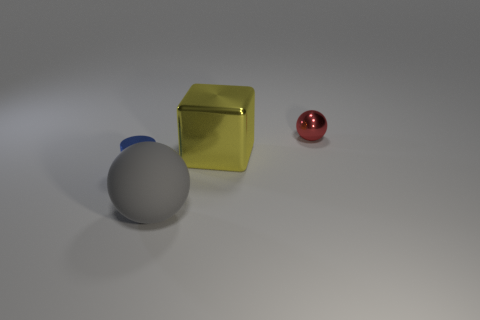Add 2 green matte spheres. How many objects exist? 6 Subtract all cylinders. How many objects are left? 3 Subtract all tiny red metallic things. Subtract all big spheres. How many objects are left? 2 Add 4 balls. How many balls are left? 6 Add 1 shiny spheres. How many shiny spheres exist? 2 Subtract 0 yellow spheres. How many objects are left? 4 